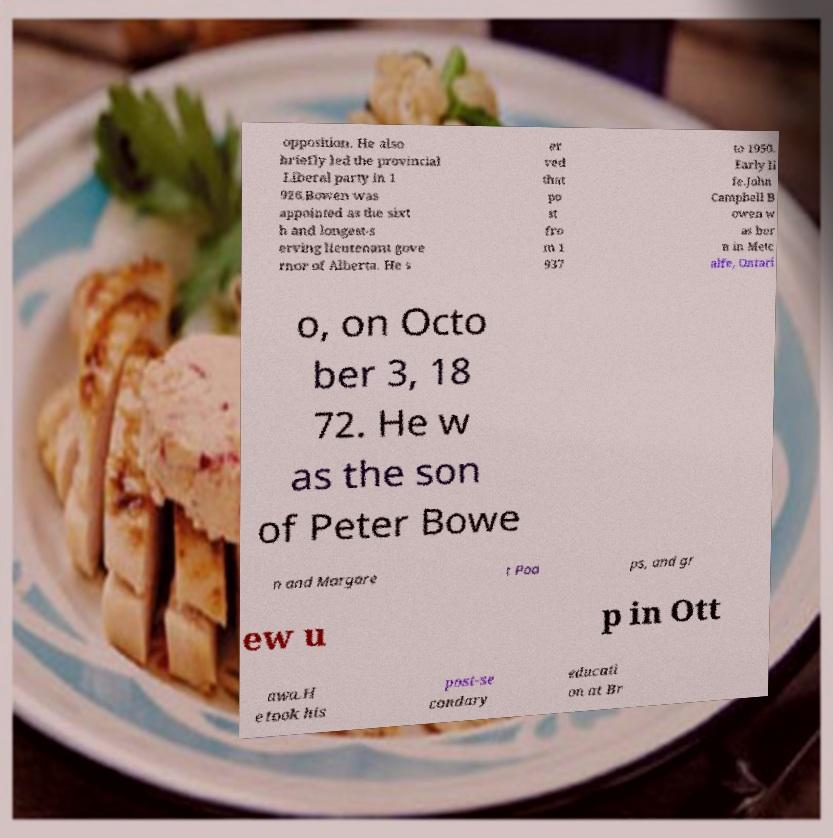I need the written content from this picture converted into text. Can you do that? opposition. He also briefly led the provincial Liberal party in 1 926.Bowen was appointed as the sixt h and longest-s erving lieutenant gove rnor of Alberta. He s er ved that po st fro m 1 937 to 1950. Early li fe.John Campbell B owen w as bor n in Metc alfe, Ontari o, on Octo ber 3, 18 72. He w as the son of Peter Bowe n and Margare t Poa ps, and gr ew u p in Ott awa.H e took his post-se condary educati on at Br 